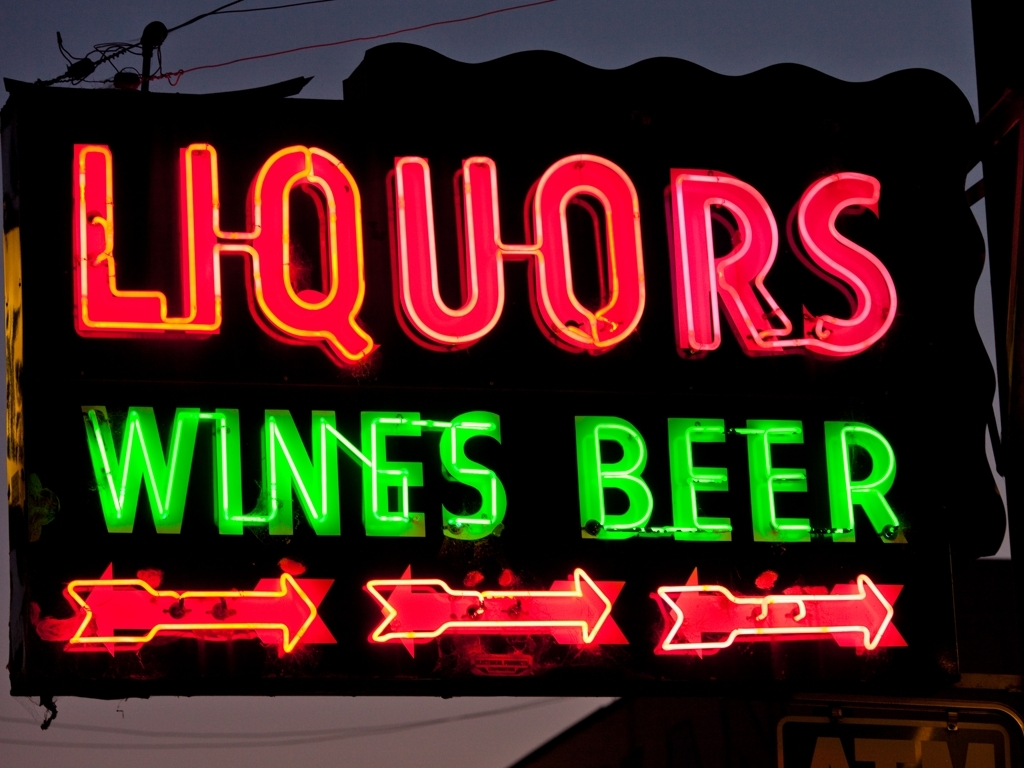Can you tell me what this sign is indicating? This neon sign is indicating the presence of a liquor store that also sells wine and beer. It seems to be a traditional storefront sign designed to catch the attention of passersby at dusk or during the night with its bright neon lights. Does the sign seem to belong to a specific period or style? The neon sign has a retro look that might suggest it comes from the mid-20th century when such signage was popular for businesses. The style reflects the vintage Americana vibe often associated with classic diners, theaters, and drive-ins from that era. 